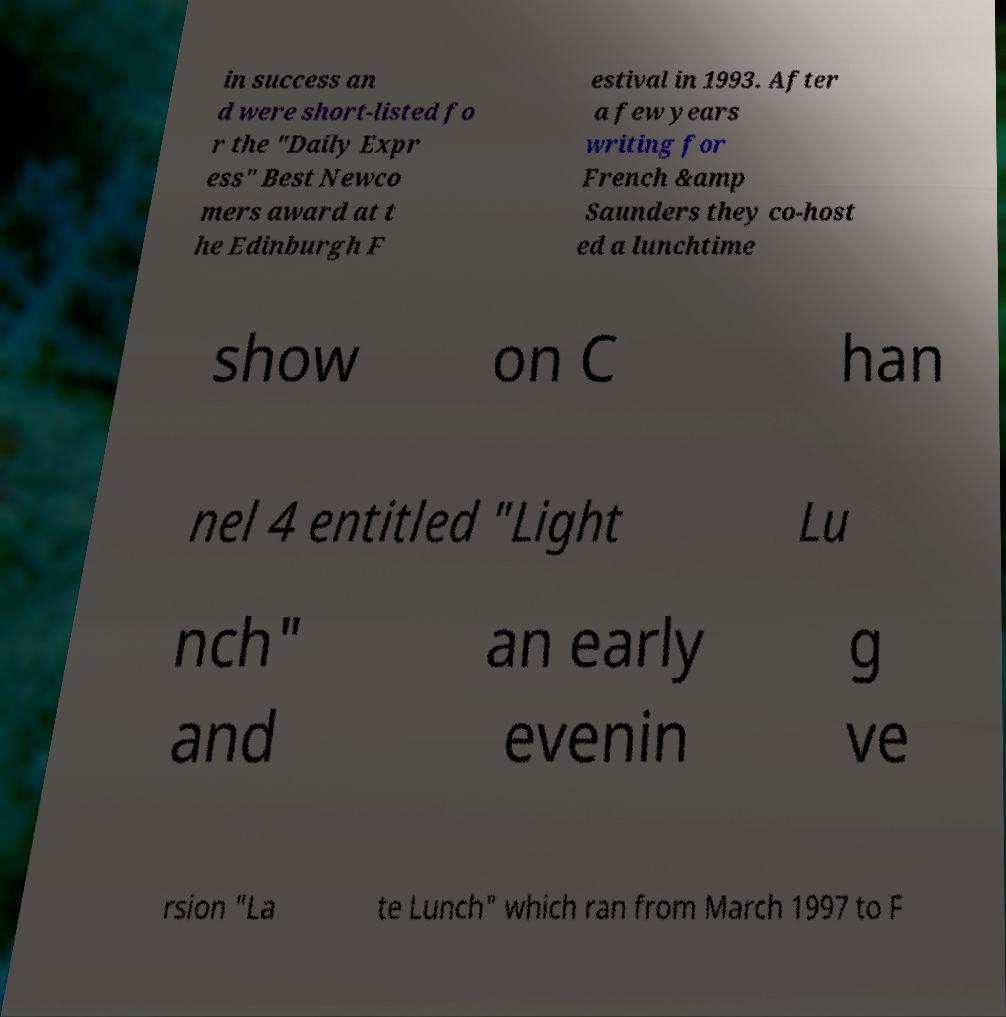Please identify and transcribe the text found in this image. in success an d were short-listed fo r the "Daily Expr ess" Best Newco mers award at t he Edinburgh F estival in 1993. After a few years writing for French &amp Saunders they co-host ed a lunchtime show on C han nel 4 entitled "Light Lu nch" and an early evenin g ve rsion "La te Lunch" which ran from March 1997 to F 